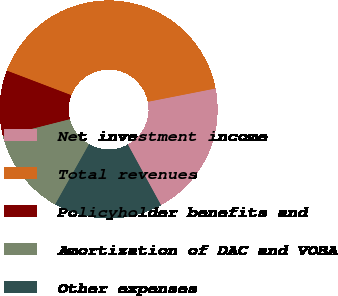<chart> <loc_0><loc_0><loc_500><loc_500><pie_chart><fcel>Net investment income<fcel>Total revenues<fcel>Policyholder benefits and<fcel>Amortization of DAC and VOBA<fcel>Other expenses<nl><fcel>20.13%<fcel>41.11%<fcel>9.75%<fcel>12.89%<fcel>16.12%<nl></chart> 